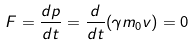Convert formula to latex. <formula><loc_0><loc_0><loc_500><loc_500>F = \frac { d p } { d t } = \frac { d } { d t } ( \gamma m _ { 0 } v ) = 0</formula> 